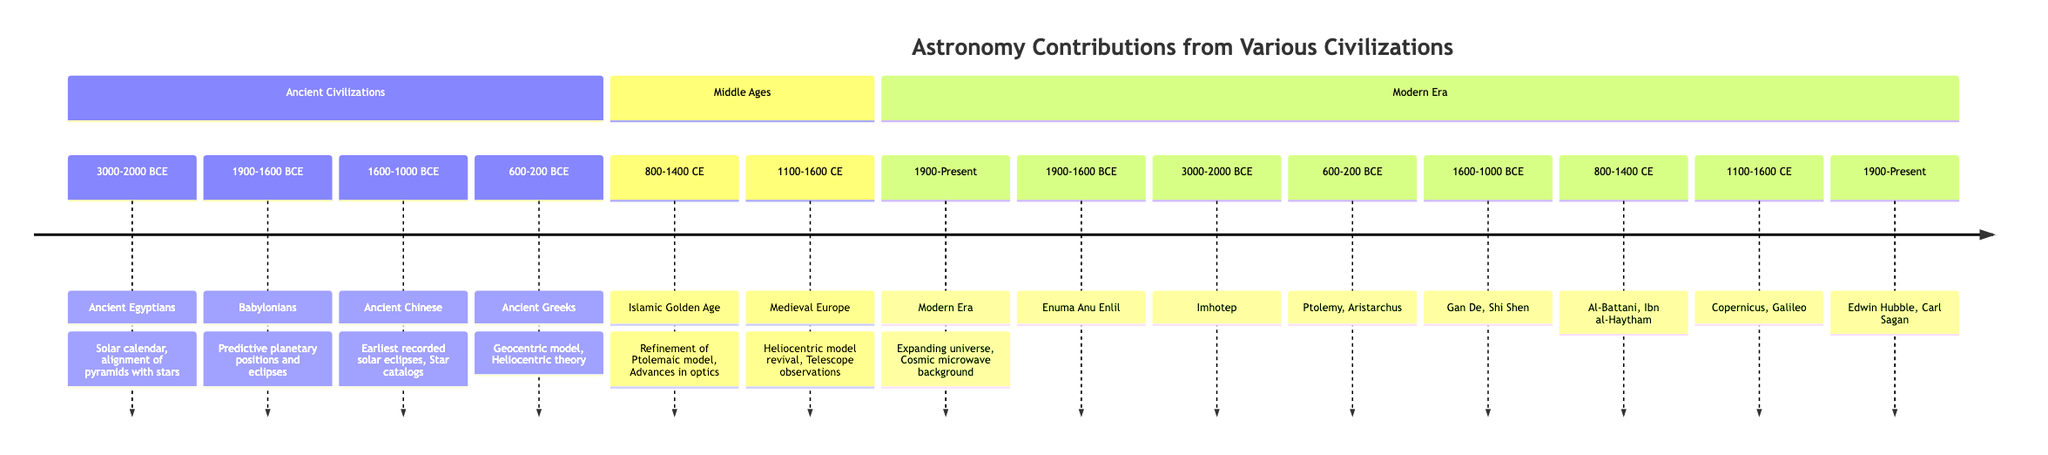What civilization contributed to the predictive planetary positions? According to the diagram, the Babylonians made significant contributions to predictive planetary positions, as indicated in the section for Ancient Civilizations.
Answer: Babylonians What was the notable contribution of Ancient Greeks? The diagram lists the Ancient Greeks' notable contributions, including the development of the Geocentric model and the Heliocentric theory, highlighting their influence on astronomy.
Answer: Geocentric model, Heliocentric theory Who was a significant figure during the Islamic Golden Age of astronomy? The diagram mentions notable figures from the Islamic Golden Age and specifies that Al-Battani and Ibn al-Haytham were key contributors during this era, focusing on their advancements in optics and refining the Ptolemaic model.
Answer: Al-Battani, Ibn al-Haytham When was the heliocentric model revived in Medieval Europe? The diagram shows the time frame for the revival of the heliocentric model as occurring between 1100 and 1600 CE, indicating the period when these advancements were made in Medieval Europe.
Answer: 1100-1600 CE What major contribution was made in the Modern Era? The diagram states that a critical contribution in the Modern Era was the understanding of the expanding universe and the discovery of the cosmic microwave background, showcasing the advances made in this period.
Answer: Expanding universe, Cosmic microwave background Which ancient civilization is associated with the solar calendar? The diagram identifies the Ancient Egyptians as the civilization that contributed to the development of the solar calendar, illustrating the early understanding of time measurement in astronomy.
Answer: Ancient Egyptians What centuries fall under the section of the Middle Ages? The diagram specifies that the Middle Ages in this timeline are represented from 800-1400 CE, indicating the contributions and advancements in astronomy during this historical period.
Answer: 800-1400 CE Who developed the earliest recorded solar eclipses? In the timeline, it is noted that the Ancient Chinese were responsible for the earliest recorded solar eclipses, which emphasizes their significant contributions to understanding celestial events.
Answer: Ancient Chinese Which figure is known for contributions during the Modern Era? The diagram highlights Edwin Hubble and Carl Sagan as notable figures in the Modern Era, pointing out their significant roles in the field of astronomy during this time.
Answer: Edwin Hubble, Carl Sagan 